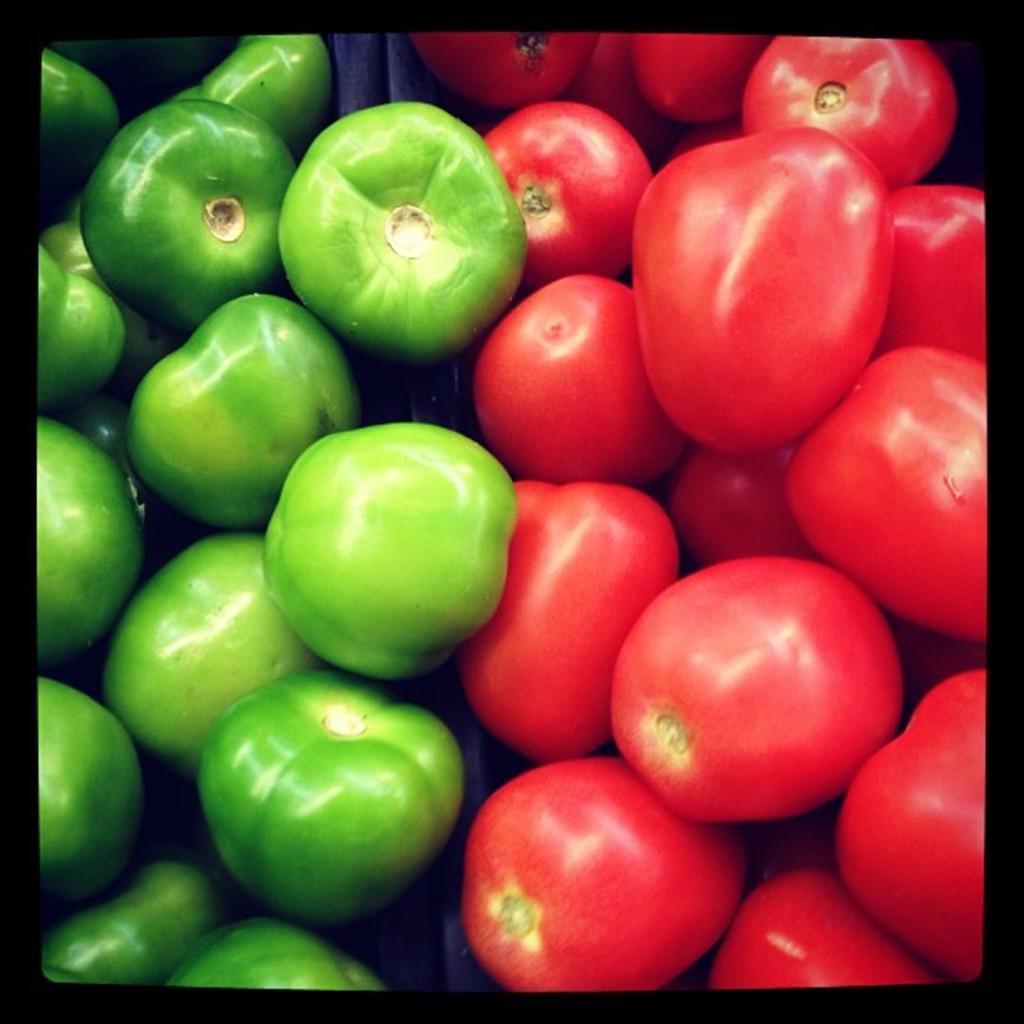Describe this image in one or two sentences. These are tomatoes. 